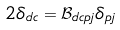<formula> <loc_0><loc_0><loc_500><loc_500>2 \delta _ { d c } = \mathcal { B } _ { d c p j } \delta _ { p j }</formula> 